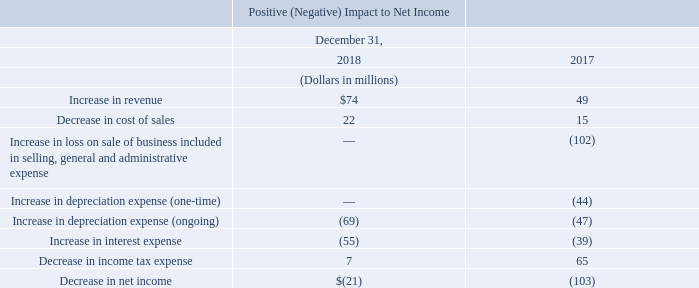The failed-sale-leaseback accounting treatment had the following effects on our consolidated results of operations for the years ended December 31, 2018 and 2017:
After factoring in the costs to sell the data centers and colocation business, excluding the impact from the failed-sale-leaseback accounting treatment, the sale resulted in a $20 million gain as a result of the aggregate value of the proceeds we received exceeding the carrying value of the assets sold and liabilities assumed. Based on the fair market values of the failed-sale-leaseback assets, the failed-sale-leaseback accounting treatment resulted in a loss of $102 million as a result of the requirement to treat a certain amount of the pre-tax cash proceeds from the sale of the assets as though it were the result of a financing obligation. The combined net loss of $82 million was included in selling, general and administrative expenses in our consolidated statement of operations for the year ended December 31, 2017.
Effective November 3, 2016, which is the date we entered into the agreement to sell a portion of our data centers and colocation business, we ceased recording depreciation of the property, plant and equipment to be sold and amortization of the business’s intangible assets in accordance with applicable accounting rules. Otherwise, we estimate that we would have recorded additional depreciation and amortization expense of $67 million from January 1, 2017 through May 1, 2017.
Upon adopting ASU 2016-02, accounting for the failed sale leaseback is no longer applicable based on our facts and circumstances, and the real estate assets and corresponding financing obligation were derecognized from our consolidated financial statements. Please see “Leases” (ASU 2016-02) in Note 1— Background and Summary of Significant Accounting Policies for additional information on the impact the new lease standard will have on the accounting for the failed-sale-leaseback.
What is the 2018 increase in revenue?
Answer scale should be: million. $74. Where was the combined net loss of $82 million reported in? In selling, general and administrative expenses in our consolidated statement of operations for the year ended december 31, 2017. The table contains the consolidated results of operations for which years? 2018, 2017. Which year had a larger decrease in the cost of sales? 22>15
Answer: 2018. What is the change in the increase in revenue in 2018 from 2017?
Answer scale should be: million. $74-$49
Answer: 25. What is the average increase in revenue across 2017 and 2018?
Answer scale should be: million. ($74+$49)/2
Answer: 61.5. 